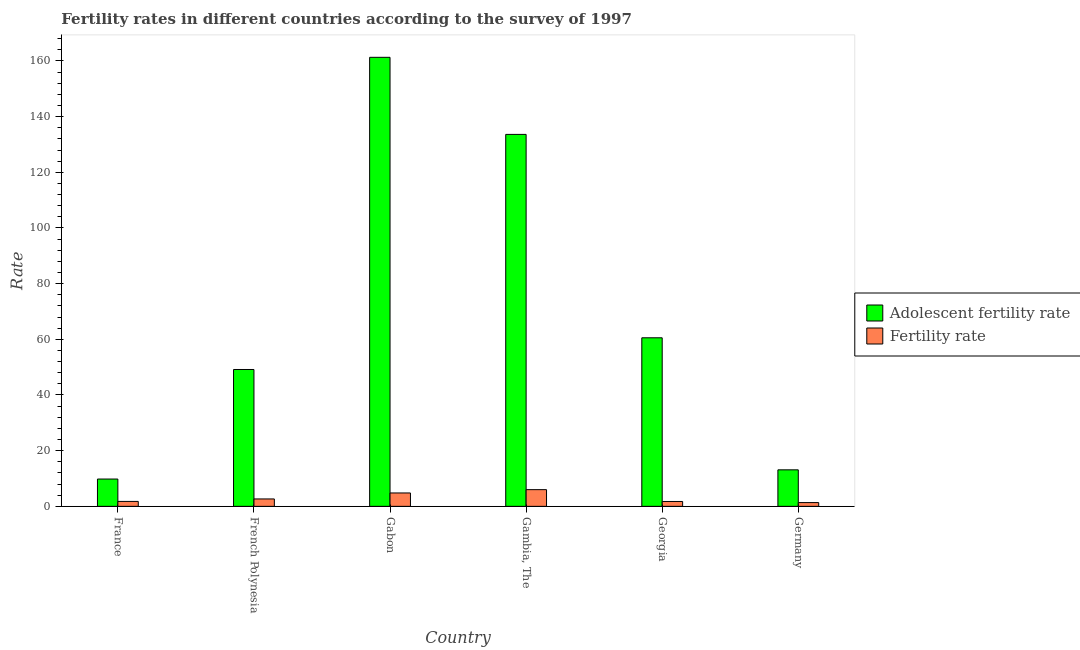How many groups of bars are there?
Your answer should be compact. 6. Are the number of bars on each tick of the X-axis equal?
Your response must be concise. Yes. How many bars are there on the 6th tick from the left?
Your response must be concise. 2. What is the label of the 4th group of bars from the left?
Offer a terse response. Gambia, The. In how many cases, is the number of bars for a given country not equal to the number of legend labels?
Provide a succinct answer. 0. What is the fertility rate in France?
Provide a succinct answer. 1.77. Across all countries, what is the maximum adolescent fertility rate?
Keep it short and to the point. 161.29. Across all countries, what is the minimum adolescent fertility rate?
Your response must be concise. 9.81. In which country was the adolescent fertility rate maximum?
Your response must be concise. Gabon. In which country was the fertility rate minimum?
Your answer should be compact. Germany. What is the total adolescent fertility rate in the graph?
Your answer should be compact. 427.52. What is the difference between the fertility rate in Georgia and that in Germany?
Ensure brevity in your answer.  0.4. What is the difference between the adolescent fertility rate in Gambia, The and the fertility rate in Gabon?
Offer a terse response. 128.8. What is the average adolescent fertility rate per country?
Make the answer very short. 71.25. What is the difference between the adolescent fertility rate and fertility rate in Gabon?
Your answer should be very brief. 156.48. In how many countries, is the adolescent fertility rate greater than 4 ?
Your response must be concise. 6. What is the ratio of the adolescent fertility rate in Gambia, The to that in Georgia?
Offer a terse response. 2.21. Is the fertility rate in Gabon less than that in Georgia?
Your response must be concise. No. Is the difference between the fertility rate in France and Georgia greater than the difference between the adolescent fertility rate in France and Georgia?
Ensure brevity in your answer.  Yes. What is the difference between the highest and the second highest fertility rate?
Your response must be concise. 1.19. What is the difference between the highest and the lowest adolescent fertility rate?
Ensure brevity in your answer.  151.48. Is the sum of the fertility rate in French Polynesia and Germany greater than the maximum adolescent fertility rate across all countries?
Offer a terse response. No. What does the 2nd bar from the left in Gabon represents?
Your answer should be very brief. Fertility rate. What does the 1st bar from the right in French Polynesia represents?
Offer a terse response. Fertility rate. How many bars are there?
Provide a short and direct response. 12. Are all the bars in the graph horizontal?
Your answer should be compact. No. How many countries are there in the graph?
Your answer should be compact. 6. What is the difference between two consecutive major ticks on the Y-axis?
Provide a succinct answer. 20. Are the values on the major ticks of Y-axis written in scientific E-notation?
Keep it short and to the point. No. Does the graph contain grids?
Your answer should be compact. No. How are the legend labels stacked?
Provide a short and direct response. Vertical. What is the title of the graph?
Make the answer very short. Fertility rates in different countries according to the survey of 1997. What is the label or title of the Y-axis?
Provide a short and direct response. Rate. What is the Rate in Adolescent fertility rate in France?
Offer a very short reply. 9.81. What is the Rate in Fertility rate in France?
Your answer should be very brief. 1.77. What is the Rate of Adolescent fertility rate in French Polynesia?
Ensure brevity in your answer.  49.16. What is the Rate of Fertility rate in French Polynesia?
Your answer should be very brief. 2.66. What is the Rate in Adolescent fertility rate in Gabon?
Give a very brief answer. 161.29. What is the Rate of Fertility rate in Gabon?
Ensure brevity in your answer.  4.81. What is the Rate in Adolescent fertility rate in Gambia, The?
Offer a very short reply. 133.6. What is the Rate in Fertility rate in Gambia, The?
Provide a succinct answer. 6. What is the Rate of Adolescent fertility rate in Georgia?
Keep it short and to the point. 60.54. What is the Rate of Fertility rate in Georgia?
Keep it short and to the point. 1.75. What is the Rate in Adolescent fertility rate in Germany?
Keep it short and to the point. 13.11. What is the Rate of Fertility rate in Germany?
Your answer should be compact. 1.35. Across all countries, what is the maximum Rate in Adolescent fertility rate?
Your answer should be very brief. 161.29. Across all countries, what is the maximum Rate of Fertility rate?
Provide a succinct answer. 6. Across all countries, what is the minimum Rate in Adolescent fertility rate?
Keep it short and to the point. 9.81. Across all countries, what is the minimum Rate of Fertility rate?
Keep it short and to the point. 1.35. What is the total Rate of Adolescent fertility rate in the graph?
Make the answer very short. 427.52. What is the total Rate of Fertility rate in the graph?
Offer a terse response. 18.33. What is the difference between the Rate of Adolescent fertility rate in France and that in French Polynesia?
Your answer should be very brief. -39.35. What is the difference between the Rate in Fertility rate in France and that in French Polynesia?
Your response must be concise. -0.89. What is the difference between the Rate in Adolescent fertility rate in France and that in Gabon?
Keep it short and to the point. -151.48. What is the difference between the Rate of Fertility rate in France and that in Gabon?
Keep it short and to the point. -3.04. What is the difference between the Rate in Adolescent fertility rate in France and that in Gambia, The?
Offer a very short reply. -123.8. What is the difference between the Rate in Fertility rate in France and that in Gambia, The?
Make the answer very short. -4.22. What is the difference between the Rate of Adolescent fertility rate in France and that in Georgia?
Make the answer very short. -50.74. What is the difference between the Rate in Fertility rate in France and that in Georgia?
Offer a very short reply. 0.02. What is the difference between the Rate of Adolescent fertility rate in France and that in Germany?
Offer a terse response. -3.31. What is the difference between the Rate in Fertility rate in France and that in Germany?
Ensure brevity in your answer.  0.42. What is the difference between the Rate of Adolescent fertility rate in French Polynesia and that in Gabon?
Give a very brief answer. -112.13. What is the difference between the Rate in Fertility rate in French Polynesia and that in Gabon?
Make the answer very short. -2.15. What is the difference between the Rate of Adolescent fertility rate in French Polynesia and that in Gambia, The?
Your answer should be very brief. -84.44. What is the difference between the Rate in Fertility rate in French Polynesia and that in Gambia, The?
Your answer should be compact. -3.33. What is the difference between the Rate of Adolescent fertility rate in French Polynesia and that in Georgia?
Provide a short and direct response. -11.38. What is the difference between the Rate in Fertility rate in French Polynesia and that in Georgia?
Provide a succinct answer. 0.91. What is the difference between the Rate in Adolescent fertility rate in French Polynesia and that in Germany?
Your answer should be compact. 36.05. What is the difference between the Rate of Fertility rate in French Polynesia and that in Germany?
Make the answer very short. 1.31. What is the difference between the Rate of Adolescent fertility rate in Gabon and that in Gambia, The?
Ensure brevity in your answer.  27.69. What is the difference between the Rate in Fertility rate in Gabon and that in Gambia, The?
Your answer should be compact. -1.19. What is the difference between the Rate of Adolescent fertility rate in Gabon and that in Georgia?
Provide a short and direct response. 100.75. What is the difference between the Rate of Fertility rate in Gabon and that in Georgia?
Your response must be concise. 3.06. What is the difference between the Rate in Adolescent fertility rate in Gabon and that in Germany?
Your answer should be compact. 148.18. What is the difference between the Rate of Fertility rate in Gabon and that in Germany?
Keep it short and to the point. 3.46. What is the difference between the Rate of Adolescent fertility rate in Gambia, The and that in Georgia?
Your answer should be very brief. 73.06. What is the difference between the Rate of Fertility rate in Gambia, The and that in Georgia?
Provide a succinct answer. 4.25. What is the difference between the Rate of Adolescent fertility rate in Gambia, The and that in Germany?
Your answer should be very brief. 120.49. What is the difference between the Rate in Fertility rate in Gambia, The and that in Germany?
Ensure brevity in your answer.  4.64. What is the difference between the Rate in Adolescent fertility rate in Georgia and that in Germany?
Ensure brevity in your answer.  47.43. What is the difference between the Rate in Fertility rate in Georgia and that in Germany?
Your response must be concise. 0.4. What is the difference between the Rate of Adolescent fertility rate in France and the Rate of Fertility rate in French Polynesia?
Offer a terse response. 7.15. What is the difference between the Rate of Adolescent fertility rate in France and the Rate of Fertility rate in Gabon?
Give a very brief answer. 5. What is the difference between the Rate in Adolescent fertility rate in France and the Rate in Fertility rate in Gambia, The?
Keep it short and to the point. 3.81. What is the difference between the Rate of Adolescent fertility rate in France and the Rate of Fertility rate in Georgia?
Provide a succinct answer. 8.06. What is the difference between the Rate in Adolescent fertility rate in France and the Rate in Fertility rate in Germany?
Your response must be concise. 8.46. What is the difference between the Rate of Adolescent fertility rate in French Polynesia and the Rate of Fertility rate in Gabon?
Make the answer very short. 44.35. What is the difference between the Rate of Adolescent fertility rate in French Polynesia and the Rate of Fertility rate in Gambia, The?
Offer a terse response. 43.17. What is the difference between the Rate of Adolescent fertility rate in French Polynesia and the Rate of Fertility rate in Georgia?
Offer a very short reply. 47.41. What is the difference between the Rate of Adolescent fertility rate in French Polynesia and the Rate of Fertility rate in Germany?
Give a very brief answer. 47.81. What is the difference between the Rate of Adolescent fertility rate in Gabon and the Rate of Fertility rate in Gambia, The?
Your answer should be very brief. 155.3. What is the difference between the Rate in Adolescent fertility rate in Gabon and the Rate in Fertility rate in Georgia?
Offer a terse response. 159.54. What is the difference between the Rate in Adolescent fertility rate in Gabon and the Rate in Fertility rate in Germany?
Provide a short and direct response. 159.94. What is the difference between the Rate in Adolescent fertility rate in Gambia, The and the Rate in Fertility rate in Georgia?
Ensure brevity in your answer.  131.85. What is the difference between the Rate in Adolescent fertility rate in Gambia, The and the Rate in Fertility rate in Germany?
Offer a very short reply. 132.25. What is the difference between the Rate of Adolescent fertility rate in Georgia and the Rate of Fertility rate in Germany?
Give a very brief answer. 59.19. What is the average Rate in Adolescent fertility rate per country?
Give a very brief answer. 71.25. What is the average Rate in Fertility rate per country?
Ensure brevity in your answer.  3.06. What is the difference between the Rate in Adolescent fertility rate and Rate in Fertility rate in France?
Offer a very short reply. 8.04. What is the difference between the Rate in Adolescent fertility rate and Rate in Fertility rate in French Polynesia?
Ensure brevity in your answer.  46.5. What is the difference between the Rate of Adolescent fertility rate and Rate of Fertility rate in Gabon?
Ensure brevity in your answer.  156.48. What is the difference between the Rate in Adolescent fertility rate and Rate in Fertility rate in Gambia, The?
Give a very brief answer. 127.61. What is the difference between the Rate in Adolescent fertility rate and Rate in Fertility rate in Georgia?
Keep it short and to the point. 58.8. What is the difference between the Rate of Adolescent fertility rate and Rate of Fertility rate in Germany?
Offer a terse response. 11.76. What is the ratio of the Rate in Adolescent fertility rate in France to that in French Polynesia?
Offer a terse response. 0.2. What is the ratio of the Rate of Fertility rate in France to that in French Polynesia?
Keep it short and to the point. 0.67. What is the ratio of the Rate in Adolescent fertility rate in France to that in Gabon?
Offer a very short reply. 0.06. What is the ratio of the Rate in Fertility rate in France to that in Gabon?
Offer a terse response. 0.37. What is the ratio of the Rate in Adolescent fertility rate in France to that in Gambia, The?
Offer a terse response. 0.07. What is the ratio of the Rate of Fertility rate in France to that in Gambia, The?
Keep it short and to the point. 0.3. What is the ratio of the Rate in Adolescent fertility rate in France to that in Georgia?
Provide a short and direct response. 0.16. What is the ratio of the Rate in Fertility rate in France to that in Georgia?
Offer a very short reply. 1.01. What is the ratio of the Rate in Adolescent fertility rate in France to that in Germany?
Offer a terse response. 0.75. What is the ratio of the Rate in Fertility rate in France to that in Germany?
Provide a short and direct response. 1.31. What is the ratio of the Rate of Adolescent fertility rate in French Polynesia to that in Gabon?
Offer a terse response. 0.3. What is the ratio of the Rate of Fertility rate in French Polynesia to that in Gabon?
Keep it short and to the point. 0.55. What is the ratio of the Rate of Adolescent fertility rate in French Polynesia to that in Gambia, The?
Offer a terse response. 0.37. What is the ratio of the Rate of Fertility rate in French Polynesia to that in Gambia, The?
Make the answer very short. 0.44. What is the ratio of the Rate of Adolescent fertility rate in French Polynesia to that in Georgia?
Give a very brief answer. 0.81. What is the ratio of the Rate of Fertility rate in French Polynesia to that in Georgia?
Your answer should be very brief. 1.52. What is the ratio of the Rate in Adolescent fertility rate in French Polynesia to that in Germany?
Offer a very short reply. 3.75. What is the ratio of the Rate of Fertility rate in French Polynesia to that in Germany?
Your answer should be compact. 1.97. What is the ratio of the Rate of Adolescent fertility rate in Gabon to that in Gambia, The?
Offer a very short reply. 1.21. What is the ratio of the Rate of Fertility rate in Gabon to that in Gambia, The?
Offer a terse response. 0.8. What is the ratio of the Rate of Adolescent fertility rate in Gabon to that in Georgia?
Make the answer very short. 2.66. What is the ratio of the Rate of Fertility rate in Gabon to that in Georgia?
Offer a terse response. 2.75. What is the ratio of the Rate of Adolescent fertility rate in Gabon to that in Germany?
Your answer should be compact. 12.3. What is the ratio of the Rate in Fertility rate in Gabon to that in Germany?
Provide a short and direct response. 3.56. What is the ratio of the Rate in Adolescent fertility rate in Gambia, The to that in Georgia?
Your answer should be very brief. 2.21. What is the ratio of the Rate of Fertility rate in Gambia, The to that in Georgia?
Your response must be concise. 3.43. What is the ratio of the Rate in Adolescent fertility rate in Gambia, The to that in Germany?
Your answer should be compact. 10.19. What is the ratio of the Rate in Fertility rate in Gambia, The to that in Germany?
Offer a terse response. 4.44. What is the ratio of the Rate in Adolescent fertility rate in Georgia to that in Germany?
Your response must be concise. 4.62. What is the ratio of the Rate of Fertility rate in Georgia to that in Germany?
Offer a terse response. 1.3. What is the difference between the highest and the second highest Rate in Adolescent fertility rate?
Keep it short and to the point. 27.69. What is the difference between the highest and the second highest Rate of Fertility rate?
Provide a short and direct response. 1.19. What is the difference between the highest and the lowest Rate of Adolescent fertility rate?
Make the answer very short. 151.48. What is the difference between the highest and the lowest Rate of Fertility rate?
Your response must be concise. 4.64. 